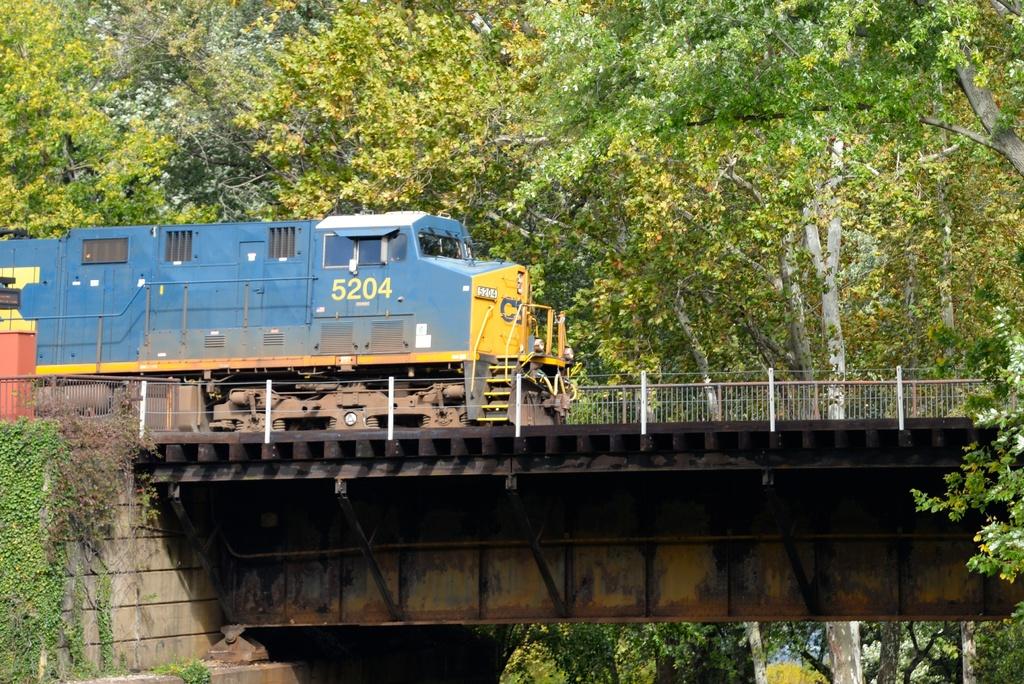What is the number of this blue and yellow train?
Offer a very short reply. 5204. 